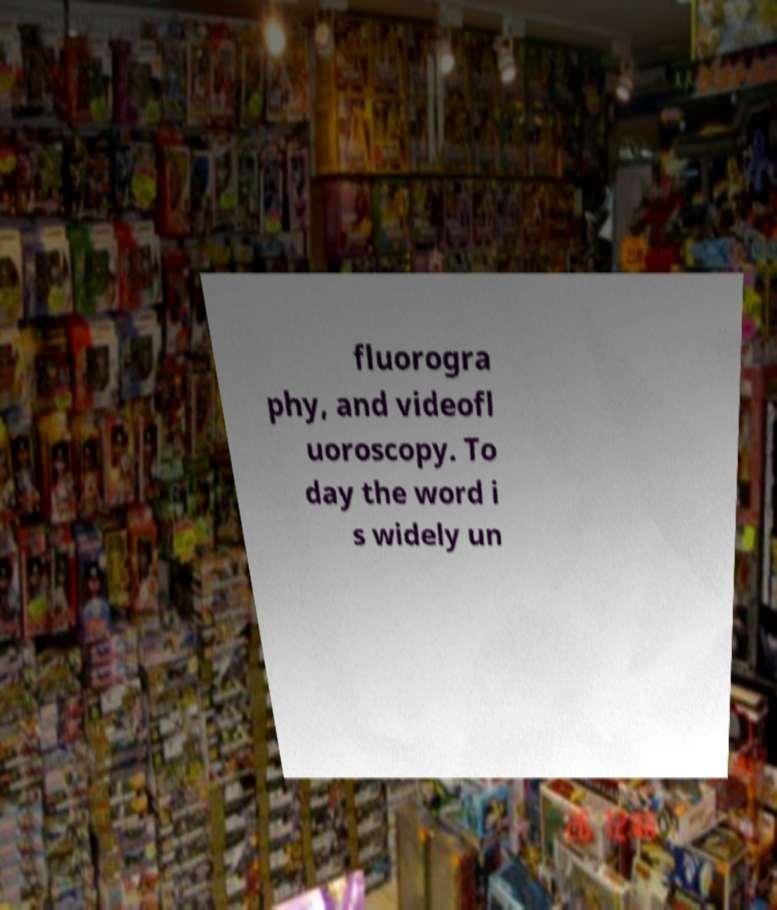I need the written content from this picture converted into text. Can you do that? fluorogra phy, and videofl uoroscopy. To day the word i s widely un 